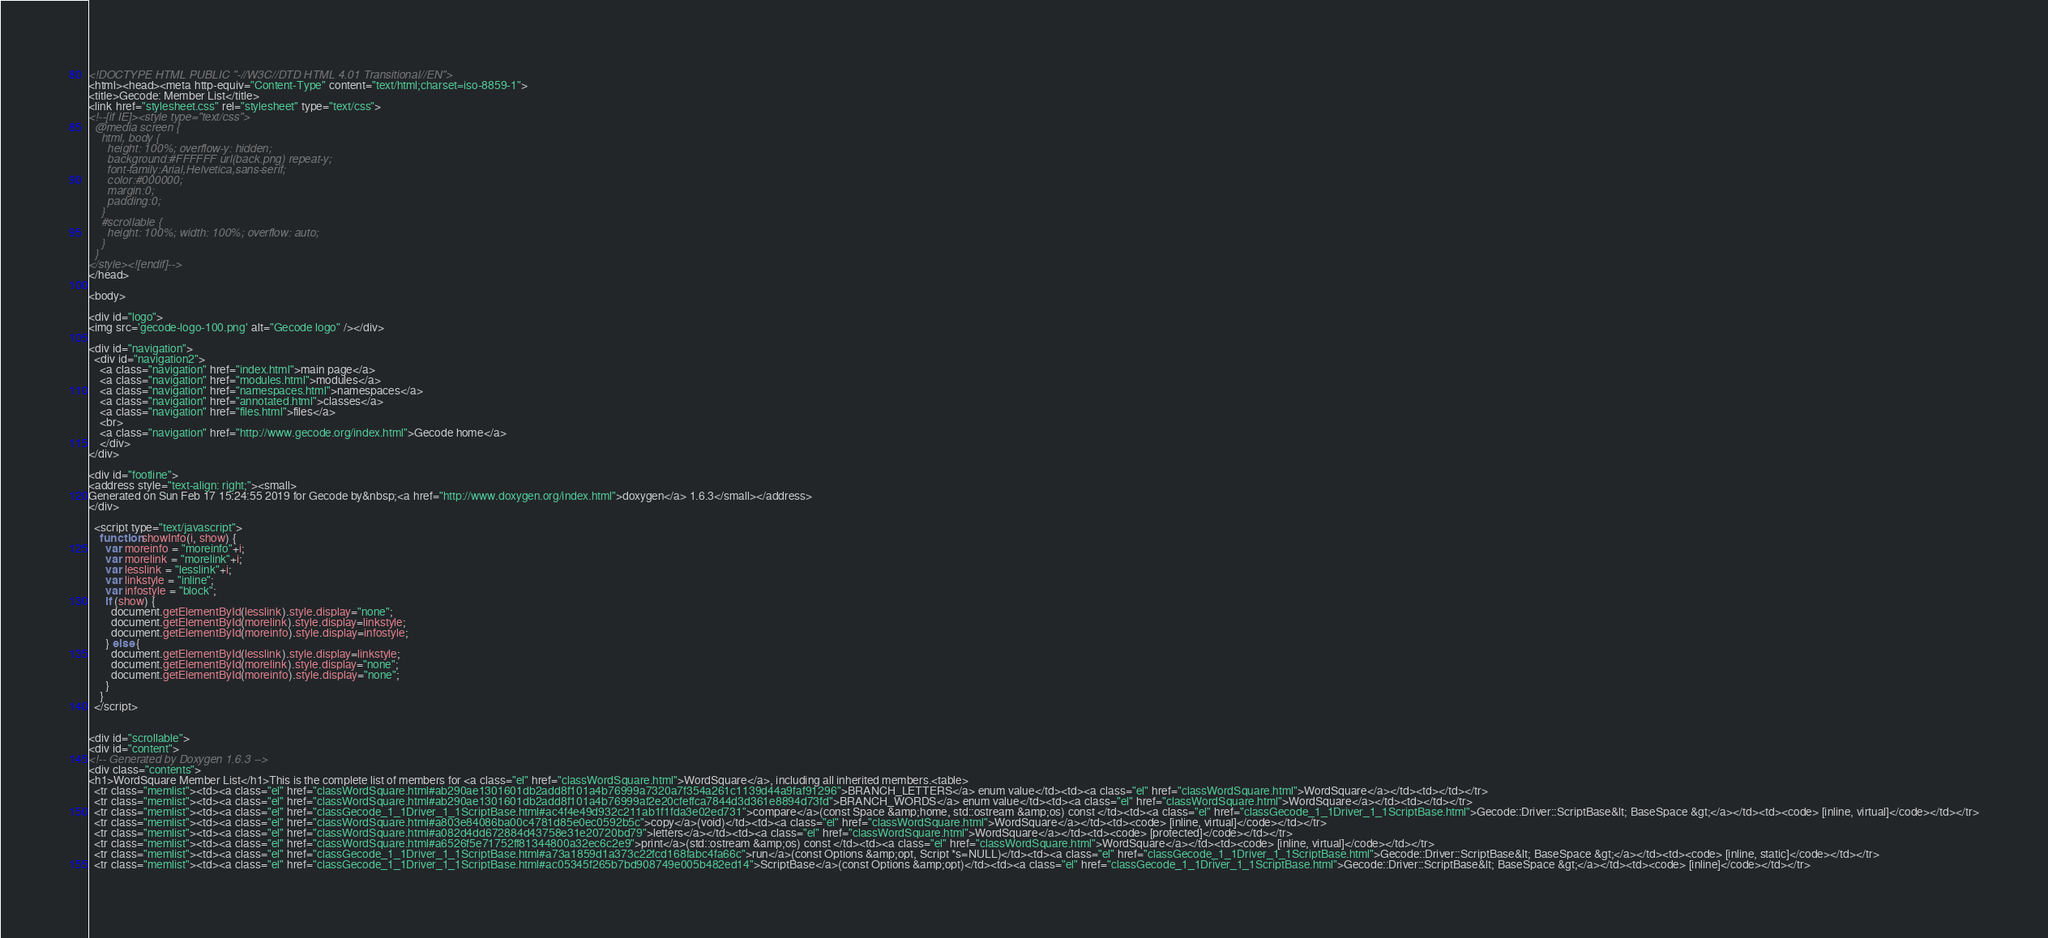Convert code to text. <code><loc_0><loc_0><loc_500><loc_500><_HTML_><!DOCTYPE HTML PUBLIC "-//W3C//DTD HTML 4.01 Transitional//EN">
<html><head><meta http-equiv="Content-Type" content="text/html;charset=iso-8859-1">
<title>Gecode: Member List</title>
<link href="stylesheet.css" rel="stylesheet" type="text/css">
<!--[if IE]><style type="text/css">
  @media screen {
    html, body {
      height: 100%; overflow-y: hidden;
      background:#FFFFFF url(back.png) repeat-y;
      font-family:Arial,Helvetica,sans-serif;
      color:#000000;
      margin:0;
      padding:0;
    }
    #scrollable {
      height: 100%; width: 100%; overflow: auto;
    }
  }
</style><![endif]-->
</head>

<body>

<div id="logo">
<img src='gecode-logo-100.png' alt="Gecode logo" /></div>

<div id="navigation">
  <div id="navigation2">
    <a class="navigation" href="index.html">main page</a>
    <a class="navigation" href="modules.html">modules</a>
    <a class="navigation" href="namespaces.html">namespaces</a>
    <a class="navigation" href="annotated.html">classes</a>
    <a class="navigation" href="files.html">files</a>
    <br>
    <a class="navigation" href="http://www.gecode.org/index.html">Gecode home</a>
    </div>
</div>

<div id="footline">
<address style="text-align: right;"><small>
Generated on Sun Feb 17 15:24:55 2019 for Gecode by&nbsp;<a href="http://www.doxygen.org/index.html">doxygen</a> 1.6.3</small></address>
</div>

  <script type="text/javascript">
    function showInfo(i, show) {
      var moreinfo = "moreinfo"+i;
      var morelink = "morelink"+i;
      var lesslink = "lesslink"+i;
      var linkstyle = "inline";
      var infostyle = "block";
      if (show) {
        document.getElementById(lesslink).style.display="none";
        document.getElementById(morelink).style.display=linkstyle;
        document.getElementById(moreinfo).style.display=infostyle;
      } else {
        document.getElementById(lesslink).style.display=linkstyle;
        document.getElementById(morelink).style.display="none";
        document.getElementById(moreinfo).style.display="none";
      }
    }
  </script>


<div id="scrollable">
<div id="content">
<!-- Generated by Doxygen 1.6.3 -->
<div class="contents">
<h1>WordSquare Member List</h1>This is the complete list of members for <a class="el" href="classWordSquare.html">WordSquare</a>, including all inherited members.<table>
  <tr class="memlist"><td><a class="el" href="classWordSquare.html#ab290ae1301601db2add8f101a4b76999a7320a7f354a261c1139d44a9faf91296">BRANCH_LETTERS</a> enum value</td><td><a class="el" href="classWordSquare.html">WordSquare</a></td><td></td></tr>
  <tr class="memlist"><td><a class="el" href="classWordSquare.html#ab290ae1301601db2add8f101a4b76999af2e20cfeffca7844d3d361e8894d73fd">BRANCH_WORDS</a> enum value</td><td><a class="el" href="classWordSquare.html">WordSquare</a></td><td></td></tr>
  <tr class="memlist"><td><a class="el" href="classGecode_1_1Driver_1_1ScriptBase.html#ac4f4e49d932c211ab1f1fda3e02ed731">compare</a>(const Space &amp;home, std::ostream &amp;os) const </td><td><a class="el" href="classGecode_1_1Driver_1_1ScriptBase.html">Gecode::Driver::ScriptBase&lt; BaseSpace &gt;</a></td><td><code> [inline, virtual]</code></td></tr>
  <tr class="memlist"><td><a class="el" href="classWordSquare.html#a803e84086ba00c4781d85e0ec0592b5c">copy</a>(void)</td><td><a class="el" href="classWordSquare.html">WordSquare</a></td><td><code> [inline, virtual]</code></td></tr>
  <tr class="memlist"><td><a class="el" href="classWordSquare.html#a082d4dd672884d43758e31e20720bd79">letters</a></td><td><a class="el" href="classWordSquare.html">WordSquare</a></td><td><code> [protected]</code></td></tr>
  <tr class="memlist"><td><a class="el" href="classWordSquare.html#a6526f5e71752ff81344800a32ec6c2e9">print</a>(std::ostream &amp;os) const </td><td><a class="el" href="classWordSquare.html">WordSquare</a></td><td><code> [inline, virtual]</code></td></tr>
  <tr class="memlist"><td><a class="el" href="classGecode_1_1Driver_1_1ScriptBase.html#a73a1859d1a373c22fcd168fabc4fa66c">run</a>(const Options &amp;opt, Script *s=NULL)</td><td><a class="el" href="classGecode_1_1Driver_1_1ScriptBase.html">Gecode::Driver::ScriptBase&lt; BaseSpace &gt;</a></td><td><code> [inline, static]</code></td></tr>
  <tr class="memlist"><td><a class="el" href="classGecode_1_1Driver_1_1ScriptBase.html#ac05345f265b7bd908749e005b482ed14">ScriptBase</a>(const Options &amp;opt)</td><td><a class="el" href="classGecode_1_1Driver_1_1ScriptBase.html">Gecode::Driver::ScriptBase&lt; BaseSpace &gt;</a></td><td><code> [inline]</code></td></tr></code> 